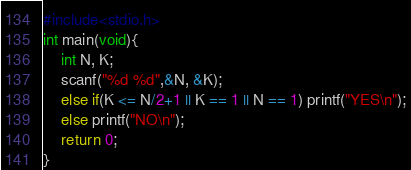Convert code to text. <code><loc_0><loc_0><loc_500><loc_500><_C_>#include<stdio.h>
int main(void){
    int N, K;
    scanf("%d %d",&N, &K);
    else if(K <= N/2+1 || K == 1 || N == 1) printf("YES\n");
    else printf("NO\n");
    return 0;
}</code> 